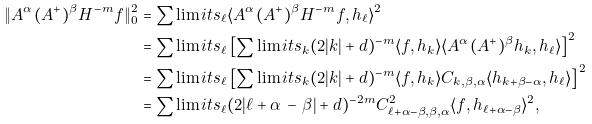<formula> <loc_0><loc_0><loc_500><loc_500>\| A ^ { \alpha } ( A ^ { + } ) ^ { \beta } H ^ { - m } f \| _ { 0 } ^ { 2 } & = \sum \lim i t s _ { \ell } \langle A ^ { \alpha } ( A ^ { + } ) ^ { \beta } H ^ { - m } f , h _ { \ell } \rangle ^ { 2 } \\ & = \sum \lim i t s _ { \ell } \left [ \sum \lim i t s _ { k } ( 2 | k | + d ) ^ { - m } \langle f , h _ { k } \rangle \langle A ^ { \alpha } ( A ^ { + } ) ^ { \beta } h _ { k } , h _ { \ell } \rangle \right ] ^ { 2 } \\ & = \sum \lim i t s _ { \ell } \left [ \sum \lim i t s _ { k } ( 2 | k | + d ) ^ { - m } \langle f , h _ { k } \rangle C _ { k , \beta , \alpha } \langle h _ { k + \beta - \alpha } , h _ { \ell } \rangle \right ] ^ { 2 } \\ & = \sum \lim i t s _ { \ell } ( 2 | \ell + \alpha \, - \, \beta | + d ) ^ { - 2 m } C ^ { 2 } _ { \ell + \alpha - \beta , \beta , \alpha } \langle f , h _ { \ell + \alpha - \beta } \rangle ^ { 2 } ,</formula> 